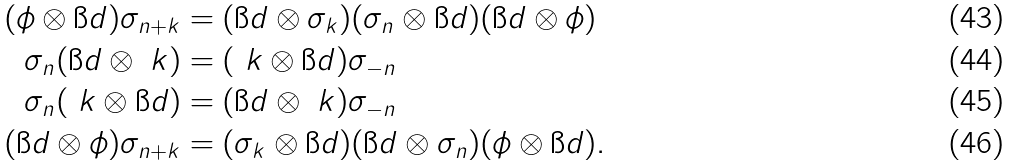Convert formula to latex. <formula><loc_0><loc_0><loc_500><loc_500>( \phi \otimes \i d ) \sigma _ { n + k } & = ( \i d \otimes \sigma _ { k } ) ( \sigma _ { n } \otimes \i d ) ( \i d \otimes \phi ) \\ \sigma _ { n } ( \i d \otimes \ k ) & = ( \ k \otimes \i d ) \sigma _ { - n } \\ \sigma _ { n } ( \ k \otimes \i d ) & = ( \i d \otimes \ k ) \sigma _ { - n } \\ ( \i d \otimes \phi ) \sigma _ { n + k } & = ( \sigma _ { k } \otimes \i d ) ( \i d \otimes \sigma _ { n } ) ( \phi \otimes \i d ) .</formula> 